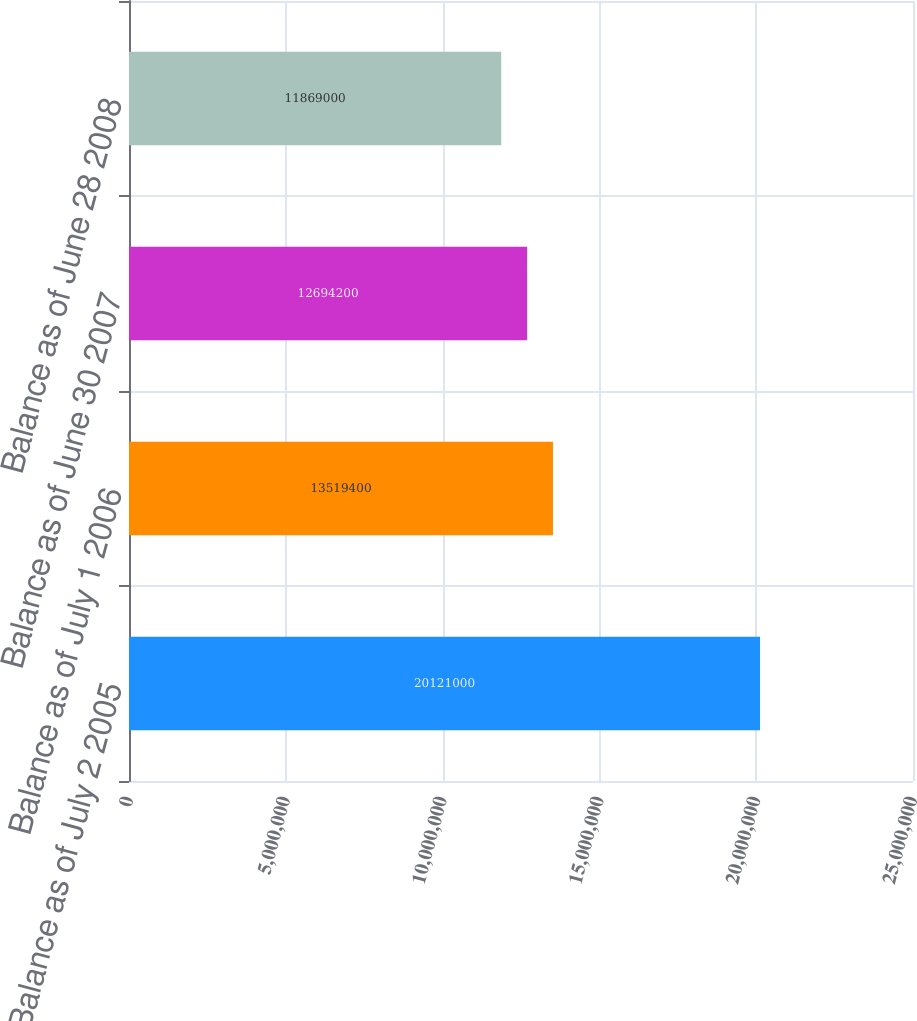Convert chart to OTSL. <chart><loc_0><loc_0><loc_500><loc_500><bar_chart><fcel>Balance as of July 2 2005<fcel>Balance as of July 1 2006<fcel>Balance as of June 30 2007<fcel>Balance as of June 28 2008<nl><fcel>2.0121e+07<fcel>1.35194e+07<fcel>1.26942e+07<fcel>1.1869e+07<nl></chart> 